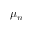Convert formula to latex. <formula><loc_0><loc_0><loc_500><loc_500>\mu _ { n }</formula> 